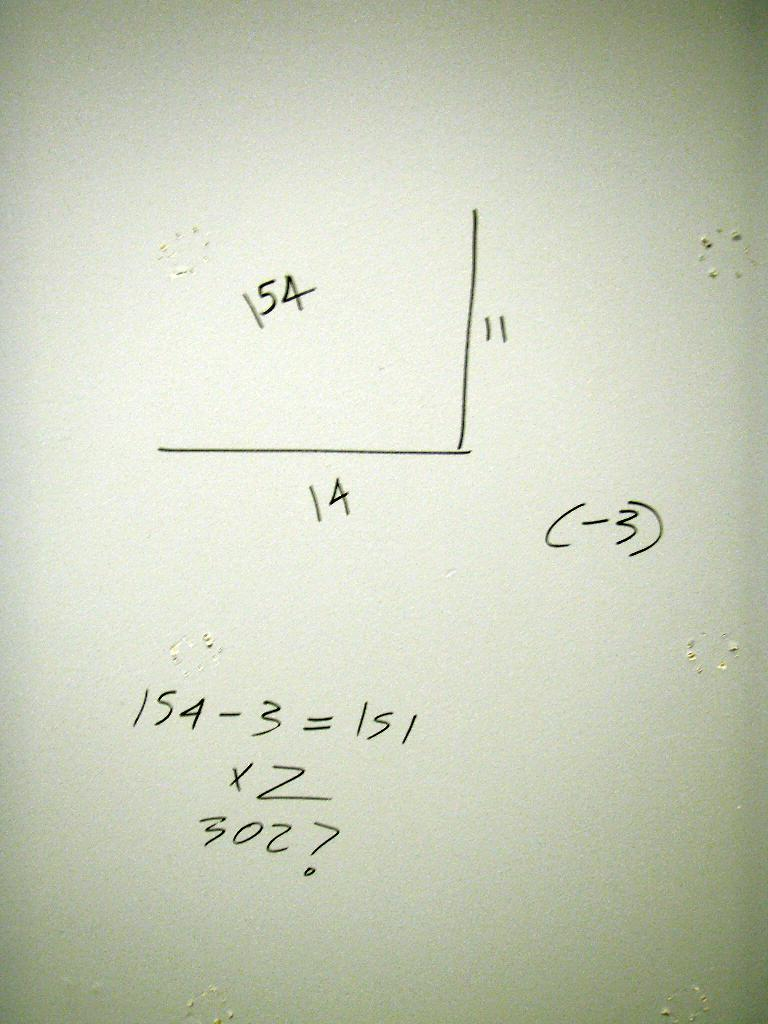<image>
Share a concise interpretation of the image provided. A math problem is shown with one of the equations being 154-3 